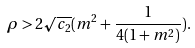<formula> <loc_0><loc_0><loc_500><loc_500>\rho > 2 \sqrt { c _ { 2 } } ( m ^ { 2 } + \frac { 1 } { 4 ( 1 + m ^ { 2 } ) } ) .</formula> 